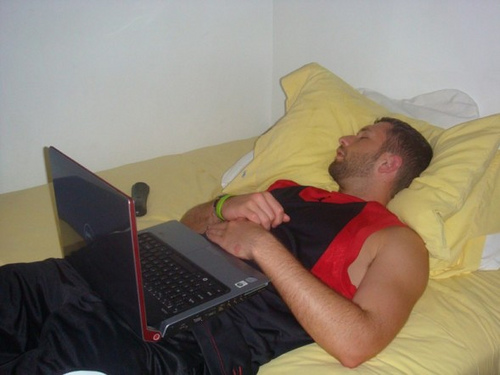Create a poetic description of the image. In the silent sanctuary of his room, sleep descends softly,
A tranquil veil over the day's tumultuous voyage.
He lies adrift between the realms of wake and dreams,
A laptop his companion, forgotten, yet loyal in its vigil.
Yellow pillows frame his peaceful countenance,
Whispering tales of rest and repose to a weary soul.
Amidst the quiet hum of life paused, a remote lies still,
A silent sentinel, guarding the sacred hush of slumber. 